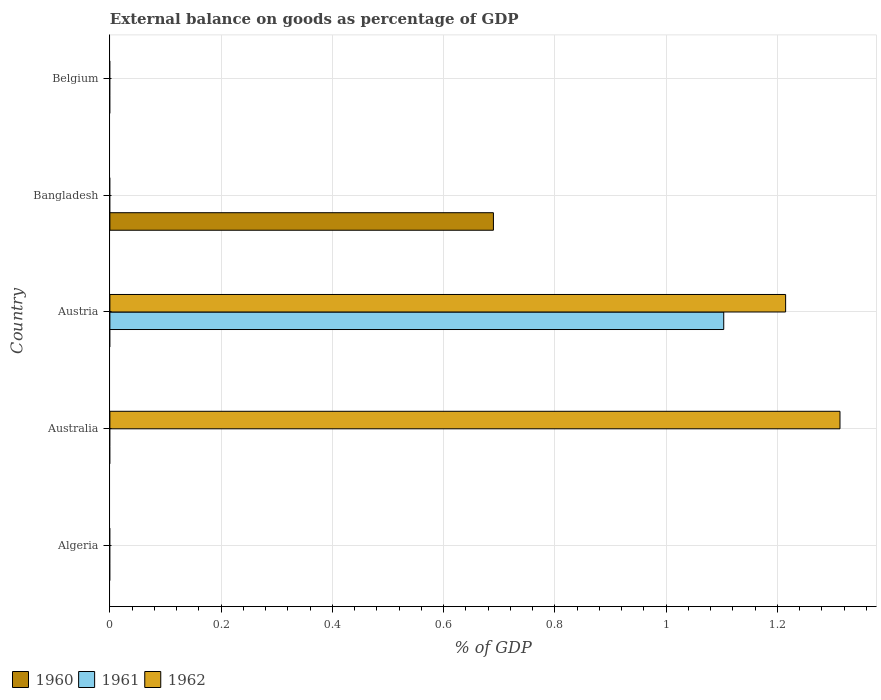How many different coloured bars are there?
Your answer should be very brief. 3. Are the number of bars per tick equal to the number of legend labels?
Your response must be concise. No. What is the label of the 5th group of bars from the top?
Offer a very short reply. Algeria. What is the external balance on goods as percentage of GDP in 1961 in Bangladesh?
Ensure brevity in your answer.  0. Across all countries, what is the maximum external balance on goods as percentage of GDP in 1962?
Your answer should be very brief. 1.31. What is the total external balance on goods as percentage of GDP in 1961 in the graph?
Keep it short and to the point. 1.1. What is the difference between the external balance on goods as percentage of GDP in 1961 in Belgium and the external balance on goods as percentage of GDP in 1962 in Australia?
Ensure brevity in your answer.  -1.31. What is the average external balance on goods as percentage of GDP in 1961 per country?
Make the answer very short. 0.22. What is the ratio of the external balance on goods as percentage of GDP in 1962 in Australia to that in Austria?
Make the answer very short. 1.08. What is the difference between the highest and the lowest external balance on goods as percentage of GDP in 1962?
Give a very brief answer. 1.31. How many bars are there?
Your answer should be compact. 4. How many countries are there in the graph?
Offer a very short reply. 5. What is the difference between two consecutive major ticks on the X-axis?
Keep it short and to the point. 0.2. How many legend labels are there?
Provide a succinct answer. 3. How are the legend labels stacked?
Provide a succinct answer. Horizontal. What is the title of the graph?
Make the answer very short. External balance on goods as percentage of GDP. Does "1975" appear as one of the legend labels in the graph?
Provide a short and direct response. No. What is the label or title of the X-axis?
Your response must be concise. % of GDP. What is the % of GDP in 1960 in Australia?
Offer a terse response. 0. What is the % of GDP of 1962 in Australia?
Offer a terse response. 1.31. What is the % of GDP in 1960 in Austria?
Provide a succinct answer. 0. What is the % of GDP in 1961 in Austria?
Provide a short and direct response. 1.1. What is the % of GDP of 1962 in Austria?
Provide a succinct answer. 1.21. What is the % of GDP of 1960 in Bangladesh?
Make the answer very short. 0.69. What is the % of GDP in 1961 in Bangladesh?
Your answer should be very brief. 0. Across all countries, what is the maximum % of GDP in 1960?
Ensure brevity in your answer.  0.69. Across all countries, what is the maximum % of GDP in 1961?
Ensure brevity in your answer.  1.1. Across all countries, what is the maximum % of GDP in 1962?
Provide a short and direct response. 1.31. Across all countries, what is the minimum % of GDP in 1960?
Provide a succinct answer. 0. Across all countries, what is the minimum % of GDP of 1961?
Your response must be concise. 0. What is the total % of GDP of 1960 in the graph?
Offer a terse response. 0.69. What is the total % of GDP in 1961 in the graph?
Ensure brevity in your answer.  1.1. What is the total % of GDP in 1962 in the graph?
Offer a terse response. 2.53. What is the difference between the % of GDP in 1962 in Australia and that in Austria?
Provide a short and direct response. 0.1. What is the average % of GDP in 1960 per country?
Your answer should be very brief. 0.14. What is the average % of GDP in 1961 per country?
Ensure brevity in your answer.  0.22. What is the average % of GDP of 1962 per country?
Offer a very short reply. 0.51. What is the difference between the % of GDP in 1961 and % of GDP in 1962 in Austria?
Keep it short and to the point. -0.11. What is the ratio of the % of GDP in 1962 in Australia to that in Austria?
Offer a very short reply. 1.08. What is the difference between the highest and the lowest % of GDP of 1960?
Your answer should be very brief. 0.69. What is the difference between the highest and the lowest % of GDP of 1961?
Offer a terse response. 1.1. What is the difference between the highest and the lowest % of GDP in 1962?
Offer a terse response. 1.31. 